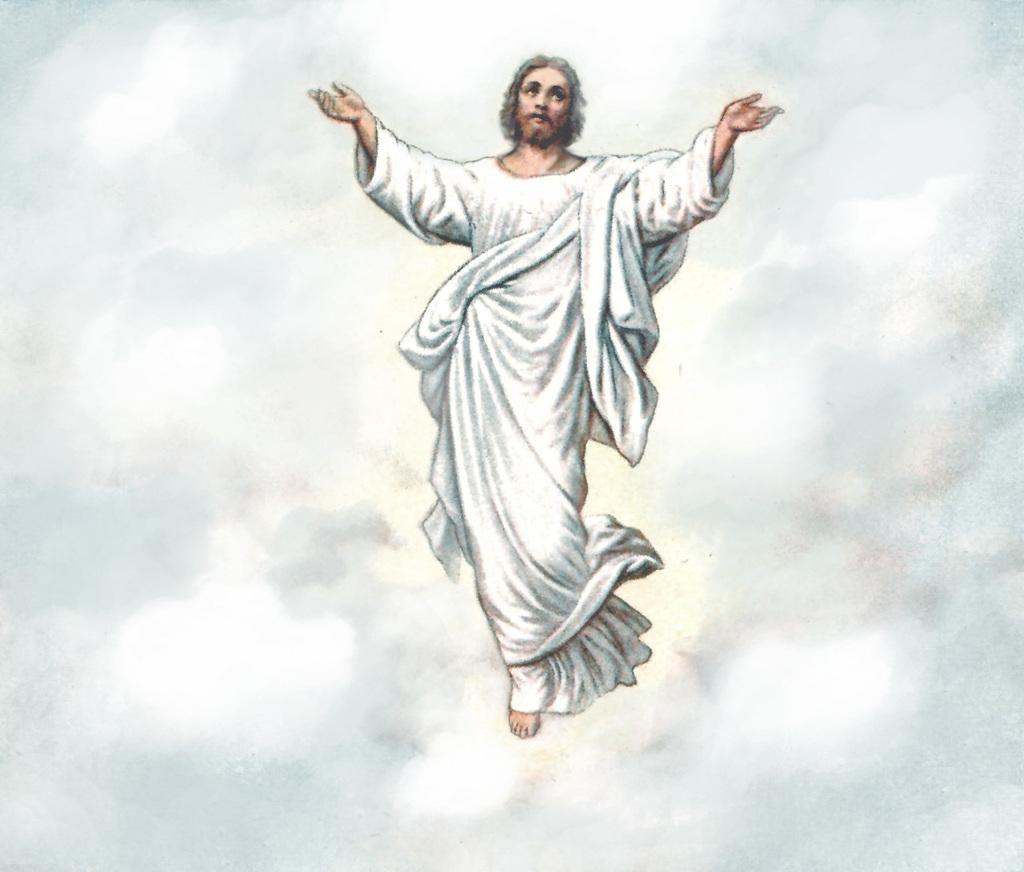What is the main subject of the image? There is a painting in the image. What is depicted in the painting? The painting depicts a person. What is the person wearing in the painting? The person is wearing a white dress. What is the condition of the hall in the image? There is no hall present in the image; it only features a painting of a person wearing a white dress. What type of cast can be seen on the person's arm in the image? There is no cast visible on the person's arm in the image, as the person is depicted wearing a white dress and no other details are mentioned. 